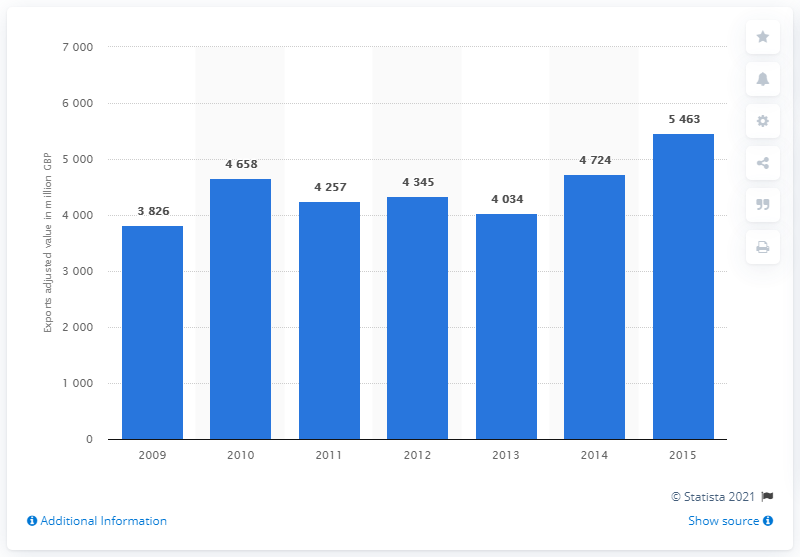Outline some significant characteristics in this image. In 2012, the value of film, TV, video, radio, and photography exports was 4,345. 